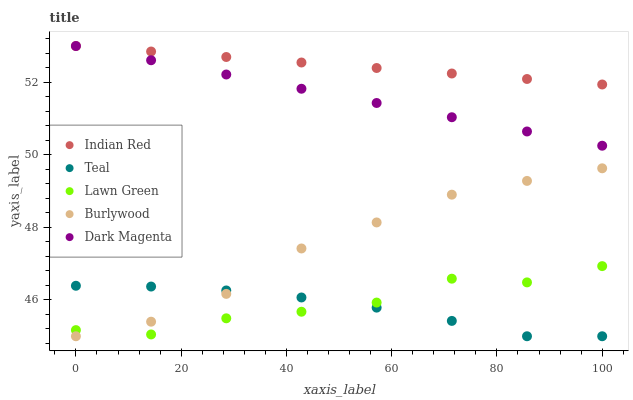Does Teal have the minimum area under the curve?
Answer yes or no. Yes. Does Indian Red have the maximum area under the curve?
Answer yes or no. Yes. Does Lawn Green have the minimum area under the curve?
Answer yes or no. No. Does Lawn Green have the maximum area under the curve?
Answer yes or no. No. Is Indian Red the smoothest?
Answer yes or no. Yes. Is Lawn Green the roughest?
Answer yes or no. Yes. Is Teal the smoothest?
Answer yes or no. No. Is Teal the roughest?
Answer yes or no. No. Does Burlywood have the lowest value?
Answer yes or no. Yes. Does Lawn Green have the lowest value?
Answer yes or no. No. Does Dark Magenta have the highest value?
Answer yes or no. Yes. Does Lawn Green have the highest value?
Answer yes or no. No. Is Burlywood less than Dark Magenta?
Answer yes or no. Yes. Is Indian Red greater than Lawn Green?
Answer yes or no. Yes. Does Teal intersect Lawn Green?
Answer yes or no. Yes. Is Teal less than Lawn Green?
Answer yes or no. No. Is Teal greater than Lawn Green?
Answer yes or no. No. Does Burlywood intersect Dark Magenta?
Answer yes or no. No. 